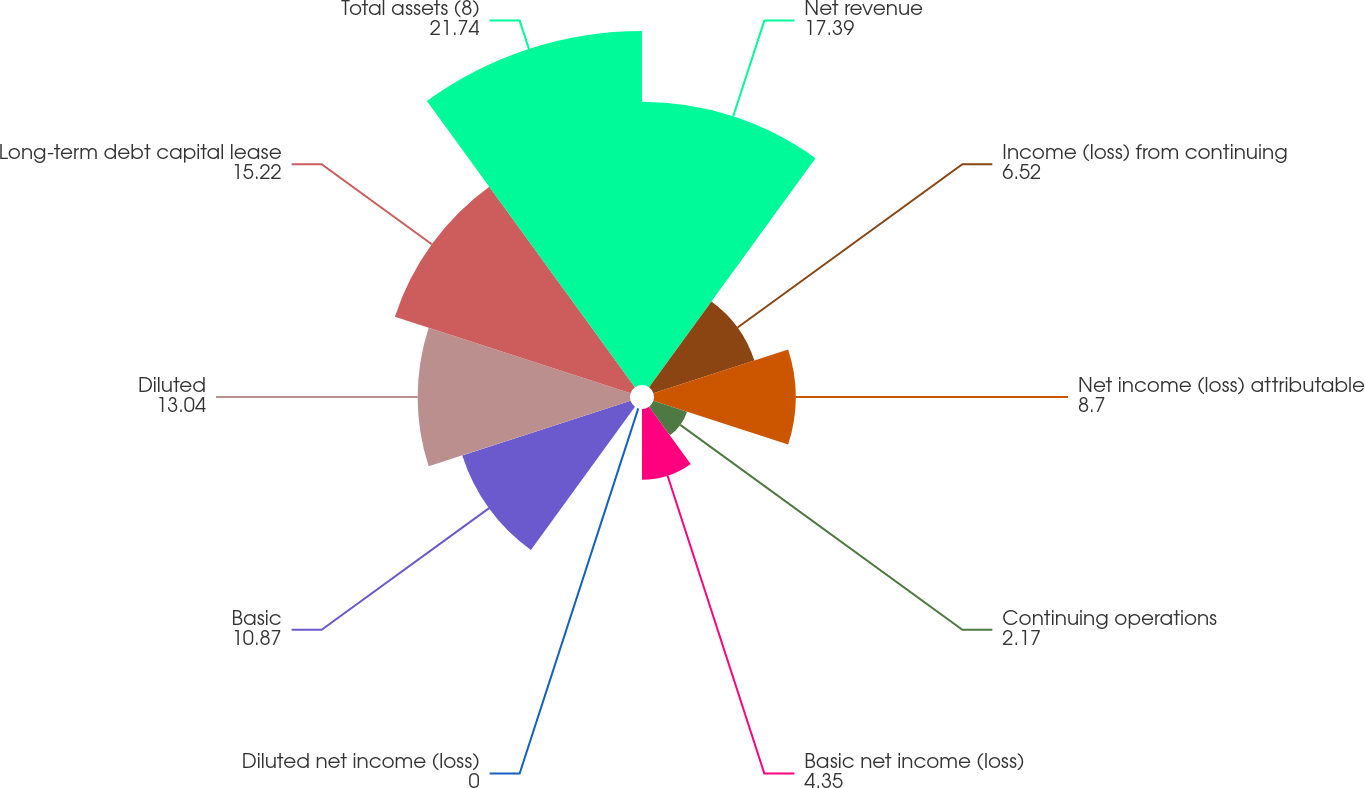<chart> <loc_0><loc_0><loc_500><loc_500><pie_chart><fcel>Net revenue<fcel>Income (loss) from continuing<fcel>Net income (loss) attributable<fcel>Continuing operations<fcel>Basic net income (loss)<fcel>Diluted net income (loss)<fcel>Basic<fcel>Diluted<fcel>Long-term debt capital lease<fcel>Total assets (8)<nl><fcel>17.39%<fcel>6.52%<fcel>8.7%<fcel>2.17%<fcel>4.35%<fcel>0.0%<fcel>10.87%<fcel>13.04%<fcel>15.22%<fcel>21.74%<nl></chart> 